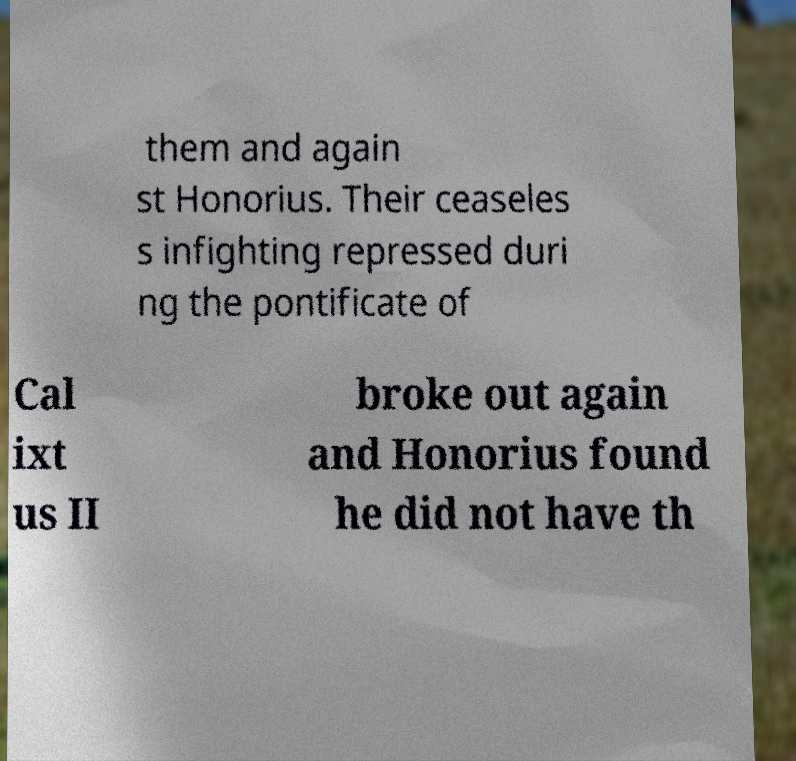What messages or text are displayed in this image? I need them in a readable, typed format. them and again st Honorius. Their ceaseles s infighting repressed duri ng the pontificate of Cal ixt us II broke out again and Honorius found he did not have th 